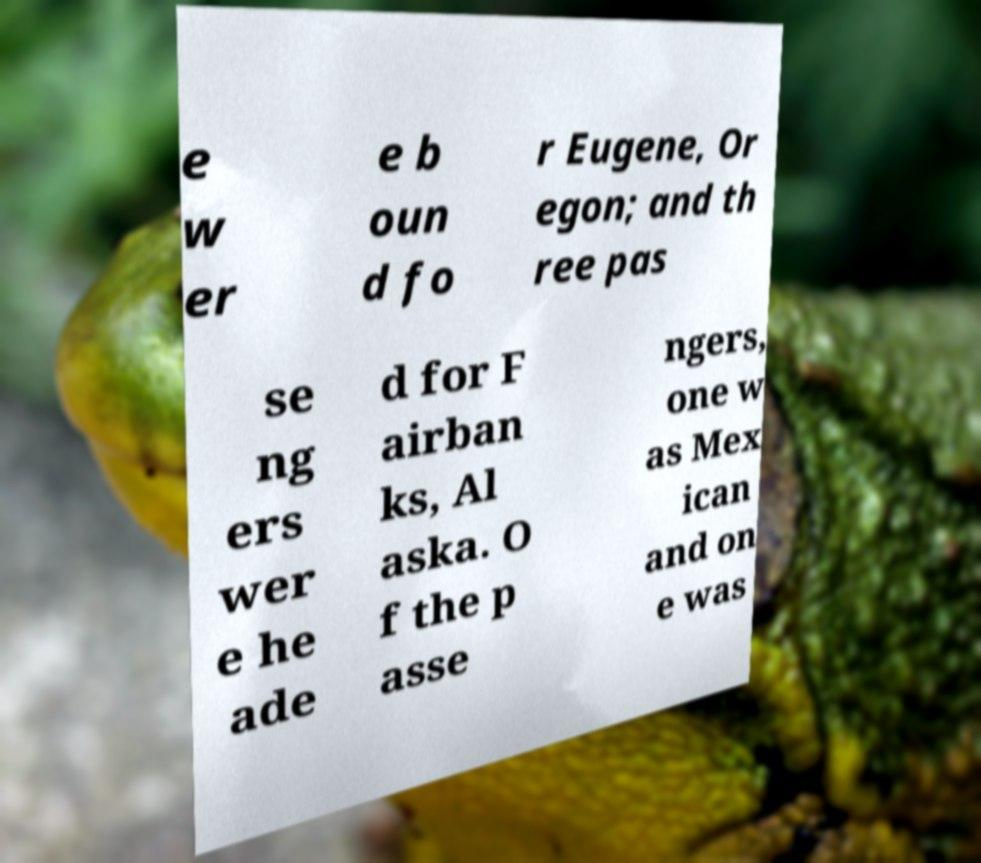There's text embedded in this image that I need extracted. Can you transcribe it verbatim? e w er e b oun d fo r Eugene, Or egon; and th ree pas se ng ers wer e he ade d for F airban ks, Al aska. O f the p asse ngers, one w as Mex ican and on e was 